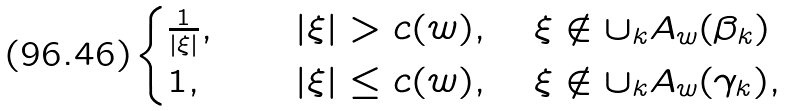<formula> <loc_0><loc_0><loc_500><loc_500>\begin{cases} \frac { 1 } { | \xi | } , & \quad | \xi | > c ( w ) , \quad \xi \notin \cup _ { k } A _ { w } ( \beta _ { k } ) \\ 1 , & \quad | \xi | \leq c ( w ) , \quad \xi \notin \cup _ { k } A _ { w } ( \gamma _ { k } ) , \end{cases}</formula> 